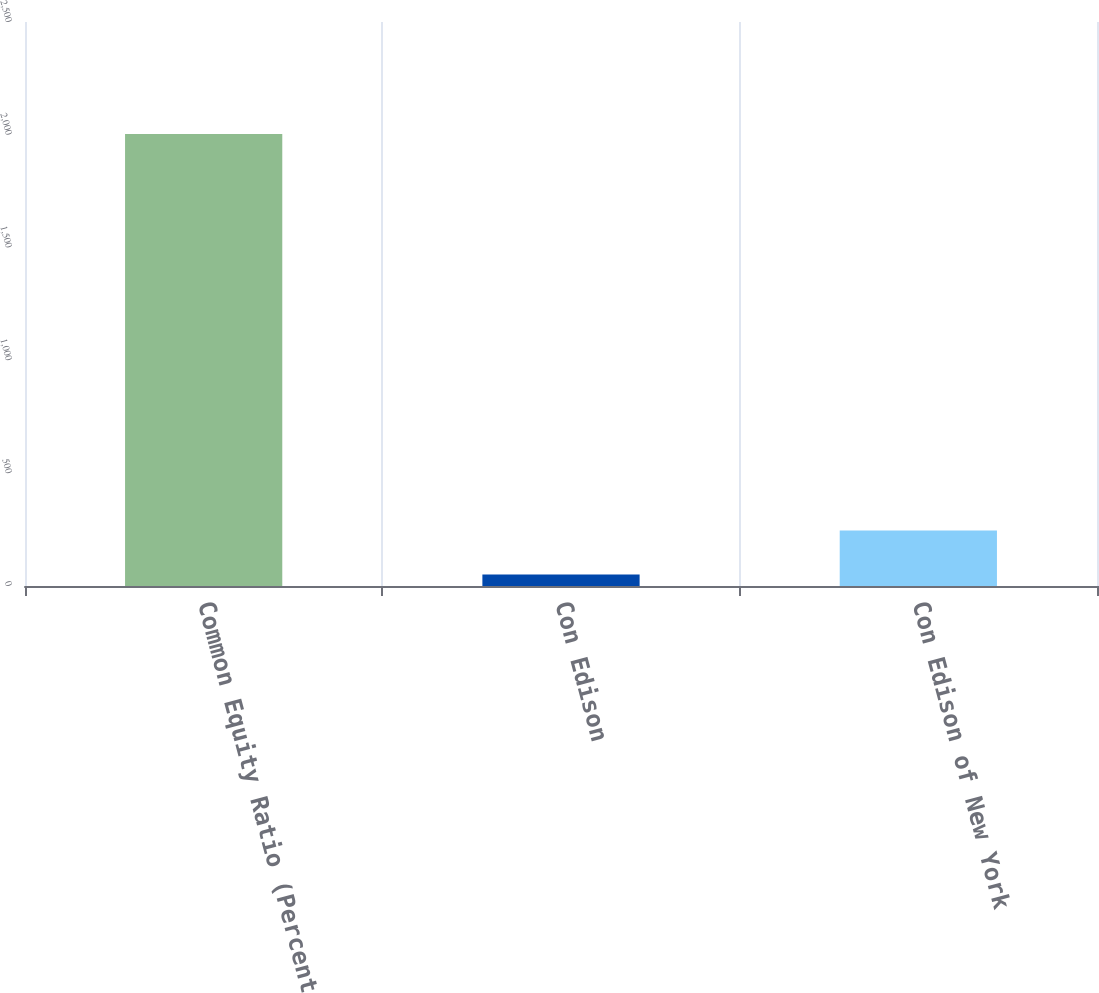Convert chart. <chart><loc_0><loc_0><loc_500><loc_500><bar_chart><fcel>Common Equity Ratio (Percent<fcel>Con Edison<fcel>Con Edison of New York<nl><fcel>2004<fcel>51<fcel>246.3<nl></chart> 